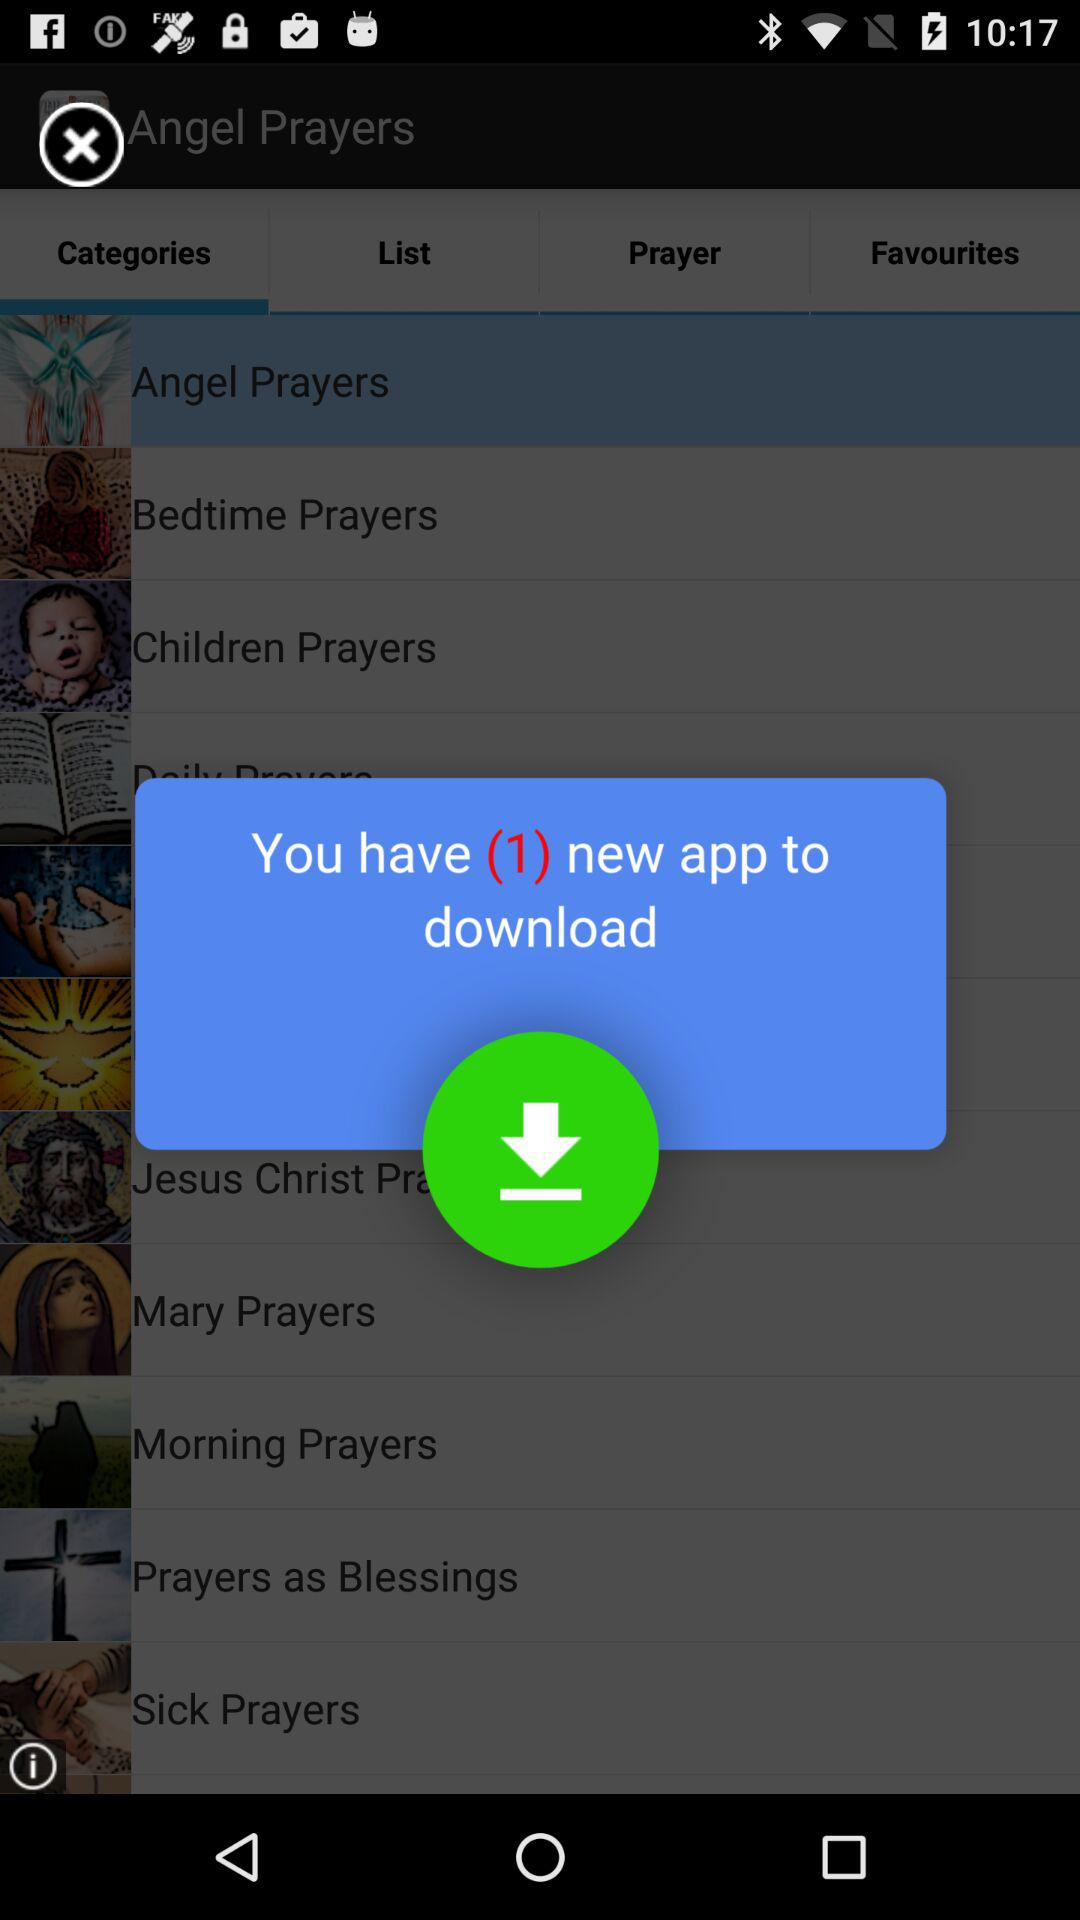Which tab is open? The open tab is "Categories". 